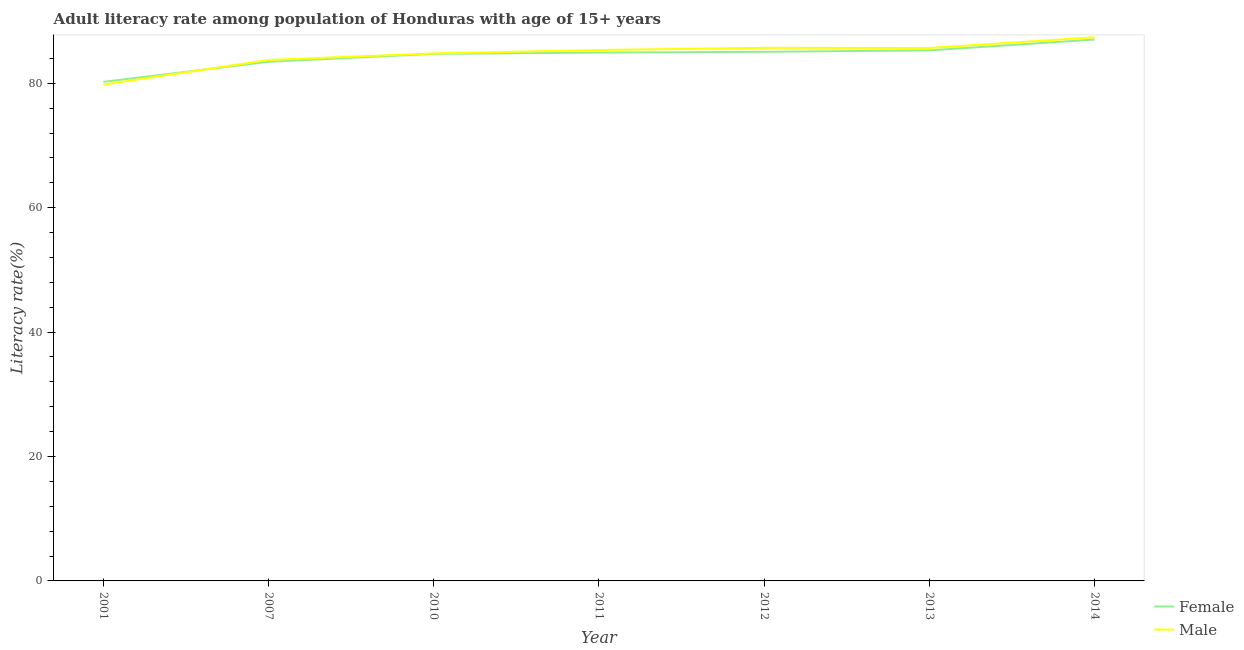Does the line corresponding to female adult literacy rate intersect with the line corresponding to male adult literacy rate?
Make the answer very short. Yes. Is the number of lines equal to the number of legend labels?
Provide a succinct answer. Yes. What is the male adult literacy rate in 2013?
Give a very brief answer. 85.67. Across all years, what is the maximum male adult literacy rate?
Offer a terse response. 87.4. Across all years, what is the minimum female adult literacy rate?
Your answer should be compact. 80.22. In which year was the female adult literacy rate maximum?
Offer a very short reply. 2014. What is the total male adult literacy rate in the graph?
Ensure brevity in your answer.  592.42. What is the difference between the male adult literacy rate in 2007 and that in 2011?
Your response must be concise. -1.6. What is the difference between the male adult literacy rate in 2012 and the female adult literacy rate in 2010?
Give a very brief answer. 0.97. What is the average female adult literacy rate per year?
Ensure brevity in your answer.  84.38. In the year 2011, what is the difference between the male adult literacy rate and female adult literacy rate?
Give a very brief answer. 0.41. What is the ratio of the female adult literacy rate in 2007 to that in 2012?
Provide a short and direct response. 0.98. Is the male adult literacy rate in 2010 less than that in 2014?
Your answer should be compact. Yes. Is the difference between the male adult literacy rate in 2011 and 2014 greater than the difference between the female adult literacy rate in 2011 and 2014?
Provide a short and direct response. Yes. What is the difference between the highest and the second highest male adult literacy rate?
Give a very brief answer. 1.7. What is the difference between the highest and the lowest male adult literacy rate?
Offer a very short reply. 7.61. In how many years, is the male adult literacy rate greater than the average male adult literacy rate taken over all years?
Make the answer very short. 5. How many lines are there?
Your answer should be very brief. 2. How many years are there in the graph?
Keep it short and to the point. 7. Are the values on the major ticks of Y-axis written in scientific E-notation?
Offer a very short reply. No. Does the graph contain any zero values?
Give a very brief answer. No. Does the graph contain grids?
Your answer should be compact. No. Where does the legend appear in the graph?
Offer a very short reply. Bottom right. How are the legend labels stacked?
Your response must be concise. Vertical. What is the title of the graph?
Your answer should be compact. Adult literacy rate among population of Honduras with age of 15+ years. What is the label or title of the Y-axis?
Your answer should be very brief. Literacy rate(%). What is the Literacy rate(%) in Female in 2001?
Provide a succinct answer. 80.22. What is the Literacy rate(%) of Male in 2001?
Give a very brief answer. 79.79. What is the Literacy rate(%) in Female in 2007?
Provide a short and direct response. 83.45. What is the Literacy rate(%) of Male in 2007?
Give a very brief answer. 83.75. What is the Literacy rate(%) in Female in 2010?
Ensure brevity in your answer.  84.73. What is the Literacy rate(%) in Male in 2010?
Keep it short and to the point. 84.79. What is the Literacy rate(%) of Female in 2011?
Give a very brief answer. 84.93. What is the Literacy rate(%) of Male in 2011?
Keep it short and to the point. 85.34. What is the Literacy rate(%) of Female in 2012?
Give a very brief answer. 85.05. What is the Literacy rate(%) in Male in 2012?
Your response must be concise. 85.7. What is the Literacy rate(%) of Female in 2013?
Ensure brevity in your answer.  85.28. What is the Literacy rate(%) in Male in 2013?
Your answer should be very brief. 85.67. What is the Literacy rate(%) in Female in 2014?
Provide a short and direct response. 87.03. What is the Literacy rate(%) in Male in 2014?
Provide a succinct answer. 87.4. Across all years, what is the maximum Literacy rate(%) of Female?
Your answer should be very brief. 87.03. Across all years, what is the maximum Literacy rate(%) of Male?
Your answer should be compact. 87.4. Across all years, what is the minimum Literacy rate(%) of Female?
Offer a very short reply. 80.22. Across all years, what is the minimum Literacy rate(%) in Male?
Provide a succinct answer. 79.79. What is the total Literacy rate(%) in Female in the graph?
Your answer should be compact. 590.69. What is the total Literacy rate(%) in Male in the graph?
Ensure brevity in your answer.  592.42. What is the difference between the Literacy rate(%) of Female in 2001 and that in 2007?
Keep it short and to the point. -3.23. What is the difference between the Literacy rate(%) in Male in 2001 and that in 2007?
Give a very brief answer. -3.96. What is the difference between the Literacy rate(%) of Female in 2001 and that in 2010?
Your response must be concise. -4.5. What is the difference between the Literacy rate(%) of Male in 2001 and that in 2010?
Keep it short and to the point. -5. What is the difference between the Literacy rate(%) in Female in 2001 and that in 2011?
Make the answer very short. -4.71. What is the difference between the Literacy rate(%) of Male in 2001 and that in 2011?
Your answer should be compact. -5.56. What is the difference between the Literacy rate(%) of Female in 2001 and that in 2012?
Provide a short and direct response. -4.83. What is the difference between the Literacy rate(%) in Male in 2001 and that in 2012?
Provide a succinct answer. -5.91. What is the difference between the Literacy rate(%) of Female in 2001 and that in 2013?
Make the answer very short. -5.06. What is the difference between the Literacy rate(%) in Male in 2001 and that in 2013?
Your answer should be compact. -5.88. What is the difference between the Literacy rate(%) in Female in 2001 and that in 2014?
Offer a very short reply. -6.8. What is the difference between the Literacy rate(%) in Male in 2001 and that in 2014?
Your answer should be compact. -7.61. What is the difference between the Literacy rate(%) of Female in 2007 and that in 2010?
Your response must be concise. -1.27. What is the difference between the Literacy rate(%) of Male in 2007 and that in 2010?
Give a very brief answer. -1.04. What is the difference between the Literacy rate(%) of Female in 2007 and that in 2011?
Provide a succinct answer. -1.48. What is the difference between the Literacy rate(%) of Male in 2007 and that in 2011?
Your answer should be very brief. -1.6. What is the difference between the Literacy rate(%) of Female in 2007 and that in 2012?
Make the answer very short. -1.6. What is the difference between the Literacy rate(%) of Male in 2007 and that in 2012?
Offer a terse response. -1.95. What is the difference between the Literacy rate(%) in Female in 2007 and that in 2013?
Your response must be concise. -1.83. What is the difference between the Literacy rate(%) in Male in 2007 and that in 2013?
Provide a short and direct response. -1.92. What is the difference between the Literacy rate(%) in Female in 2007 and that in 2014?
Your answer should be very brief. -3.57. What is the difference between the Literacy rate(%) in Male in 2007 and that in 2014?
Offer a very short reply. -3.65. What is the difference between the Literacy rate(%) in Female in 2010 and that in 2011?
Your response must be concise. -0.21. What is the difference between the Literacy rate(%) of Male in 2010 and that in 2011?
Offer a very short reply. -0.55. What is the difference between the Literacy rate(%) in Female in 2010 and that in 2012?
Your answer should be compact. -0.33. What is the difference between the Literacy rate(%) in Male in 2010 and that in 2012?
Make the answer very short. -0.91. What is the difference between the Literacy rate(%) of Female in 2010 and that in 2013?
Keep it short and to the point. -0.56. What is the difference between the Literacy rate(%) of Male in 2010 and that in 2013?
Ensure brevity in your answer.  -0.88. What is the difference between the Literacy rate(%) in Female in 2010 and that in 2014?
Your answer should be compact. -2.3. What is the difference between the Literacy rate(%) in Male in 2010 and that in 2014?
Make the answer very short. -2.61. What is the difference between the Literacy rate(%) in Female in 2011 and that in 2012?
Your answer should be very brief. -0.12. What is the difference between the Literacy rate(%) of Male in 2011 and that in 2012?
Make the answer very short. -0.35. What is the difference between the Literacy rate(%) of Female in 2011 and that in 2013?
Give a very brief answer. -0.35. What is the difference between the Literacy rate(%) in Male in 2011 and that in 2013?
Provide a short and direct response. -0.33. What is the difference between the Literacy rate(%) of Female in 2011 and that in 2014?
Offer a very short reply. -2.1. What is the difference between the Literacy rate(%) in Male in 2011 and that in 2014?
Make the answer very short. -2.05. What is the difference between the Literacy rate(%) in Female in 2012 and that in 2013?
Keep it short and to the point. -0.23. What is the difference between the Literacy rate(%) in Male in 2012 and that in 2013?
Offer a terse response. 0.03. What is the difference between the Literacy rate(%) in Female in 2012 and that in 2014?
Your answer should be very brief. -1.97. What is the difference between the Literacy rate(%) of Male in 2012 and that in 2014?
Ensure brevity in your answer.  -1.7. What is the difference between the Literacy rate(%) in Female in 2013 and that in 2014?
Your answer should be compact. -1.74. What is the difference between the Literacy rate(%) in Male in 2013 and that in 2014?
Keep it short and to the point. -1.73. What is the difference between the Literacy rate(%) of Female in 2001 and the Literacy rate(%) of Male in 2007?
Offer a terse response. -3.52. What is the difference between the Literacy rate(%) in Female in 2001 and the Literacy rate(%) in Male in 2010?
Your answer should be compact. -4.57. What is the difference between the Literacy rate(%) in Female in 2001 and the Literacy rate(%) in Male in 2011?
Your answer should be very brief. -5.12. What is the difference between the Literacy rate(%) in Female in 2001 and the Literacy rate(%) in Male in 2012?
Offer a very short reply. -5.47. What is the difference between the Literacy rate(%) of Female in 2001 and the Literacy rate(%) of Male in 2013?
Make the answer very short. -5.44. What is the difference between the Literacy rate(%) of Female in 2001 and the Literacy rate(%) of Male in 2014?
Keep it short and to the point. -7.17. What is the difference between the Literacy rate(%) in Female in 2007 and the Literacy rate(%) in Male in 2010?
Make the answer very short. -1.34. What is the difference between the Literacy rate(%) in Female in 2007 and the Literacy rate(%) in Male in 2011?
Make the answer very short. -1.89. What is the difference between the Literacy rate(%) in Female in 2007 and the Literacy rate(%) in Male in 2012?
Keep it short and to the point. -2.24. What is the difference between the Literacy rate(%) of Female in 2007 and the Literacy rate(%) of Male in 2013?
Your response must be concise. -2.22. What is the difference between the Literacy rate(%) in Female in 2007 and the Literacy rate(%) in Male in 2014?
Make the answer very short. -3.94. What is the difference between the Literacy rate(%) of Female in 2010 and the Literacy rate(%) of Male in 2011?
Your answer should be compact. -0.62. What is the difference between the Literacy rate(%) in Female in 2010 and the Literacy rate(%) in Male in 2012?
Provide a short and direct response. -0.97. What is the difference between the Literacy rate(%) of Female in 2010 and the Literacy rate(%) of Male in 2013?
Ensure brevity in your answer.  -0.94. What is the difference between the Literacy rate(%) in Female in 2010 and the Literacy rate(%) in Male in 2014?
Ensure brevity in your answer.  -2.67. What is the difference between the Literacy rate(%) of Female in 2011 and the Literacy rate(%) of Male in 2012?
Your answer should be very brief. -0.77. What is the difference between the Literacy rate(%) in Female in 2011 and the Literacy rate(%) in Male in 2013?
Keep it short and to the point. -0.74. What is the difference between the Literacy rate(%) of Female in 2011 and the Literacy rate(%) of Male in 2014?
Keep it short and to the point. -2.47. What is the difference between the Literacy rate(%) in Female in 2012 and the Literacy rate(%) in Male in 2013?
Your answer should be very brief. -0.62. What is the difference between the Literacy rate(%) of Female in 2012 and the Literacy rate(%) of Male in 2014?
Your answer should be very brief. -2.34. What is the difference between the Literacy rate(%) of Female in 2013 and the Literacy rate(%) of Male in 2014?
Make the answer very short. -2.11. What is the average Literacy rate(%) of Female per year?
Offer a very short reply. 84.38. What is the average Literacy rate(%) in Male per year?
Keep it short and to the point. 84.63. In the year 2001, what is the difference between the Literacy rate(%) of Female and Literacy rate(%) of Male?
Your answer should be compact. 0.44. In the year 2007, what is the difference between the Literacy rate(%) in Female and Literacy rate(%) in Male?
Offer a very short reply. -0.29. In the year 2010, what is the difference between the Literacy rate(%) of Female and Literacy rate(%) of Male?
Offer a very short reply. -0.06. In the year 2011, what is the difference between the Literacy rate(%) of Female and Literacy rate(%) of Male?
Give a very brief answer. -0.41. In the year 2012, what is the difference between the Literacy rate(%) of Female and Literacy rate(%) of Male?
Offer a very short reply. -0.64. In the year 2013, what is the difference between the Literacy rate(%) of Female and Literacy rate(%) of Male?
Your response must be concise. -0.38. In the year 2014, what is the difference between the Literacy rate(%) in Female and Literacy rate(%) in Male?
Your answer should be compact. -0.37. What is the ratio of the Literacy rate(%) in Female in 2001 to that in 2007?
Provide a short and direct response. 0.96. What is the ratio of the Literacy rate(%) of Male in 2001 to that in 2007?
Keep it short and to the point. 0.95. What is the ratio of the Literacy rate(%) of Female in 2001 to that in 2010?
Your answer should be very brief. 0.95. What is the ratio of the Literacy rate(%) in Male in 2001 to that in 2010?
Your answer should be compact. 0.94. What is the ratio of the Literacy rate(%) in Female in 2001 to that in 2011?
Your answer should be compact. 0.94. What is the ratio of the Literacy rate(%) of Male in 2001 to that in 2011?
Keep it short and to the point. 0.93. What is the ratio of the Literacy rate(%) of Female in 2001 to that in 2012?
Ensure brevity in your answer.  0.94. What is the ratio of the Literacy rate(%) of Female in 2001 to that in 2013?
Ensure brevity in your answer.  0.94. What is the ratio of the Literacy rate(%) in Male in 2001 to that in 2013?
Keep it short and to the point. 0.93. What is the ratio of the Literacy rate(%) of Female in 2001 to that in 2014?
Your answer should be compact. 0.92. What is the ratio of the Literacy rate(%) of Male in 2001 to that in 2014?
Your response must be concise. 0.91. What is the ratio of the Literacy rate(%) of Female in 2007 to that in 2010?
Keep it short and to the point. 0.98. What is the ratio of the Literacy rate(%) of Female in 2007 to that in 2011?
Your answer should be compact. 0.98. What is the ratio of the Literacy rate(%) in Male in 2007 to that in 2011?
Provide a succinct answer. 0.98. What is the ratio of the Literacy rate(%) of Female in 2007 to that in 2012?
Your response must be concise. 0.98. What is the ratio of the Literacy rate(%) of Male in 2007 to that in 2012?
Keep it short and to the point. 0.98. What is the ratio of the Literacy rate(%) in Female in 2007 to that in 2013?
Ensure brevity in your answer.  0.98. What is the ratio of the Literacy rate(%) of Male in 2007 to that in 2013?
Provide a short and direct response. 0.98. What is the ratio of the Literacy rate(%) of Female in 2007 to that in 2014?
Your answer should be compact. 0.96. What is the ratio of the Literacy rate(%) in Male in 2007 to that in 2014?
Offer a very short reply. 0.96. What is the ratio of the Literacy rate(%) of Female in 2010 to that in 2011?
Keep it short and to the point. 1. What is the ratio of the Literacy rate(%) of Female in 2010 to that in 2012?
Your answer should be very brief. 1. What is the ratio of the Literacy rate(%) of Male in 2010 to that in 2012?
Give a very brief answer. 0.99. What is the ratio of the Literacy rate(%) of Female in 2010 to that in 2014?
Give a very brief answer. 0.97. What is the ratio of the Literacy rate(%) in Male in 2010 to that in 2014?
Offer a terse response. 0.97. What is the ratio of the Literacy rate(%) in Female in 2011 to that in 2012?
Your answer should be very brief. 1. What is the ratio of the Literacy rate(%) in Female in 2011 to that in 2014?
Your response must be concise. 0.98. What is the ratio of the Literacy rate(%) in Male in 2011 to that in 2014?
Provide a short and direct response. 0.98. What is the ratio of the Literacy rate(%) in Female in 2012 to that in 2014?
Your answer should be compact. 0.98. What is the ratio of the Literacy rate(%) in Male in 2012 to that in 2014?
Provide a succinct answer. 0.98. What is the ratio of the Literacy rate(%) in Female in 2013 to that in 2014?
Provide a succinct answer. 0.98. What is the ratio of the Literacy rate(%) in Male in 2013 to that in 2014?
Offer a terse response. 0.98. What is the difference between the highest and the second highest Literacy rate(%) of Female?
Provide a succinct answer. 1.74. What is the difference between the highest and the second highest Literacy rate(%) of Male?
Keep it short and to the point. 1.7. What is the difference between the highest and the lowest Literacy rate(%) of Female?
Your response must be concise. 6.8. What is the difference between the highest and the lowest Literacy rate(%) in Male?
Your answer should be compact. 7.61. 